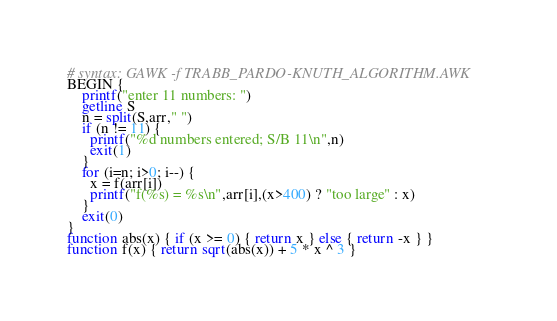<code> <loc_0><loc_0><loc_500><loc_500><_Awk_># syntax: GAWK -f TRABB_PARDO-KNUTH_ALGORITHM.AWK
BEGIN {
    printf("enter 11 numbers: ")
    getline S
    n = split(S,arr," ")
    if (n != 11) {
      printf("%d numbers entered; S/B 11\n",n)
      exit(1)
    }
    for (i=n; i>0; i--) {
      x = f(arr[i])
      printf("f(%s) = %s\n",arr[i],(x>400) ? "too large" : x)
    }
    exit(0)
}
function abs(x) { if (x >= 0) { return x } else { return -x } }
function f(x) { return sqrt(abs(x)) + 5 * x ^ 3 }
</code> 